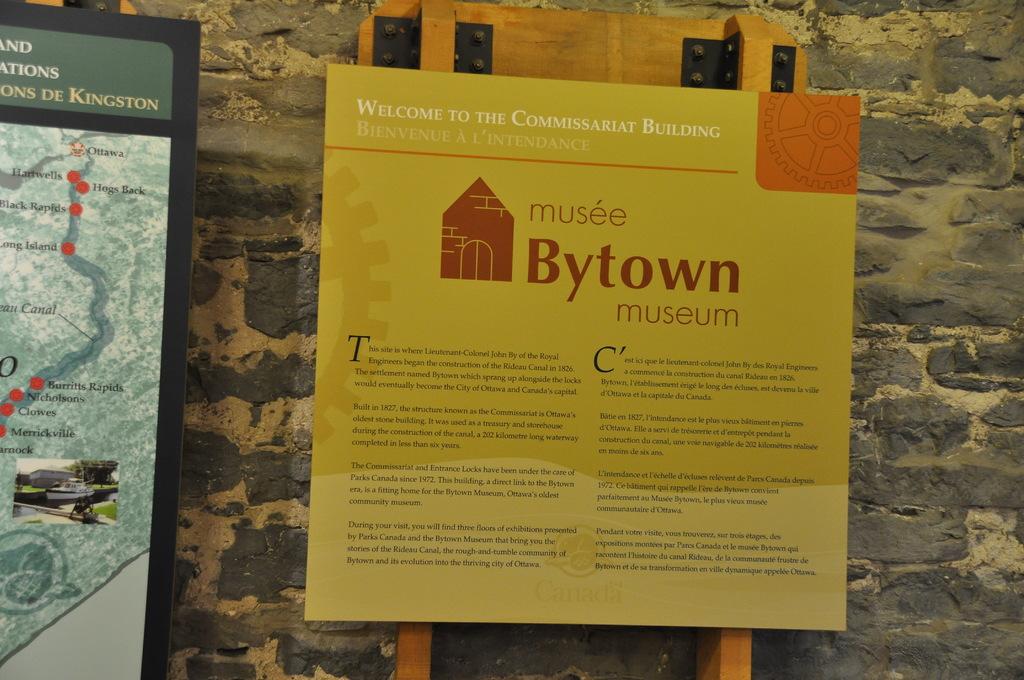What is the name of the museum?
Make the answer very short. Bytown. What is the name of the town in the upper right corner of the map?
Offer a terse response. Kingston. 